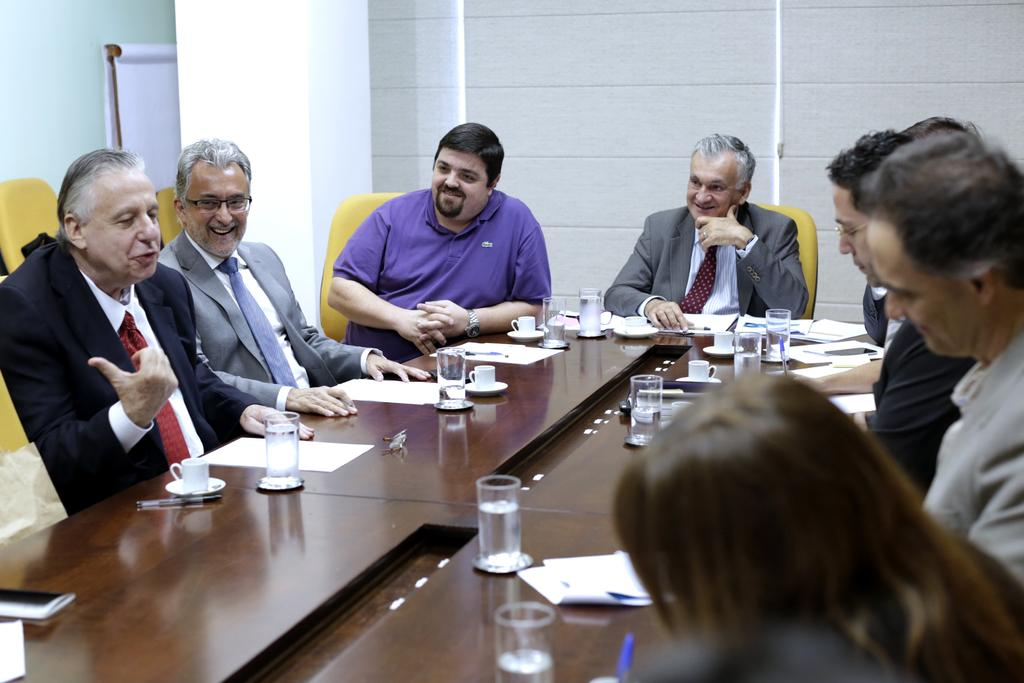What are the people in the image doing? The people in the image are sitting on the table. What can be seen on the table besides the people? Cups and glasses are present on the table. What is visible in the background of the image? There is a white wall in the background of the image. How many times has the Earth revolved around the sun since the people sat down in the image? The number of times the Earth has revolved around the sun since the people sat down in the image cannot be determined from the image itself. 